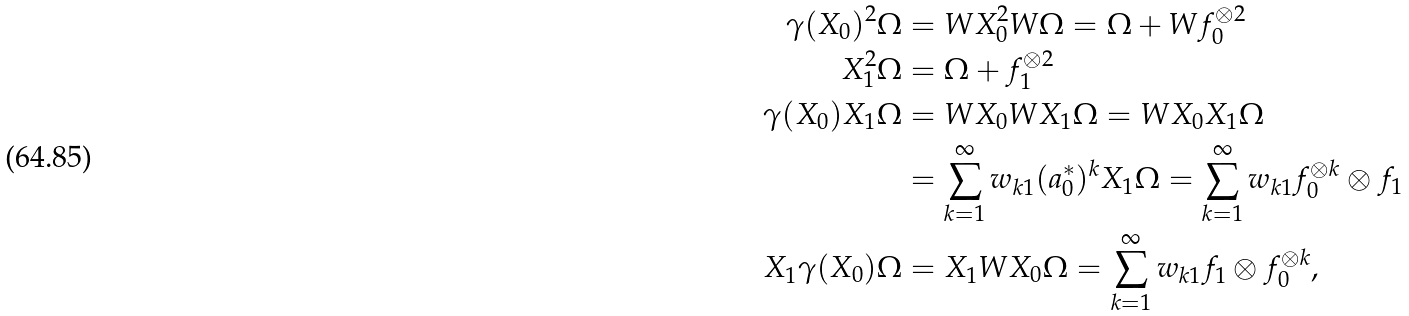Convert formula to latex. <formula><loc_0><loc_0><loc_500><loc_500>\gamma ( X _ { 0 } ) ^ { 2 } \Omega & = W X _ { 0 } ^ { 2 } W \Omega = \Omega + W f _ { 0 } ^ { \otimes 2 } \\ X _ { 1 } ^ { 2 } \Omega & = \Omega + f _ { 1 } ^ { \otimes 2 } \\ \gamma ( X _ { 0 } ) X _ { 1 } \Omega & = W X _ { 0 } W X _ { 1 } \Omega = W X _ { 0 } X _ { 1 } \Omega \\ & = \sum _ { k = 1 } ^ { \infty } w _ { k 1 } ( a _ { 0 } ^ { * } ) ^ { k } X _ { 1 } \Omega = \sum _ { k = 1 } ^ { \infty } w _ { k 1 } f _ { 0 } ^ { \otimes k } \otimes f _ { 1 } \\ X _ { 1 } \gamma ( X _ { 0 } ) \Omega & = X _ { 1 } W X _ { 0 } \Omega = \sum _ { k = 1 } ^ { \infty } w _ { k 1 } f _ { 1 } \otimes f _ { 0 } ^ { \otimes k } ,</formula> 